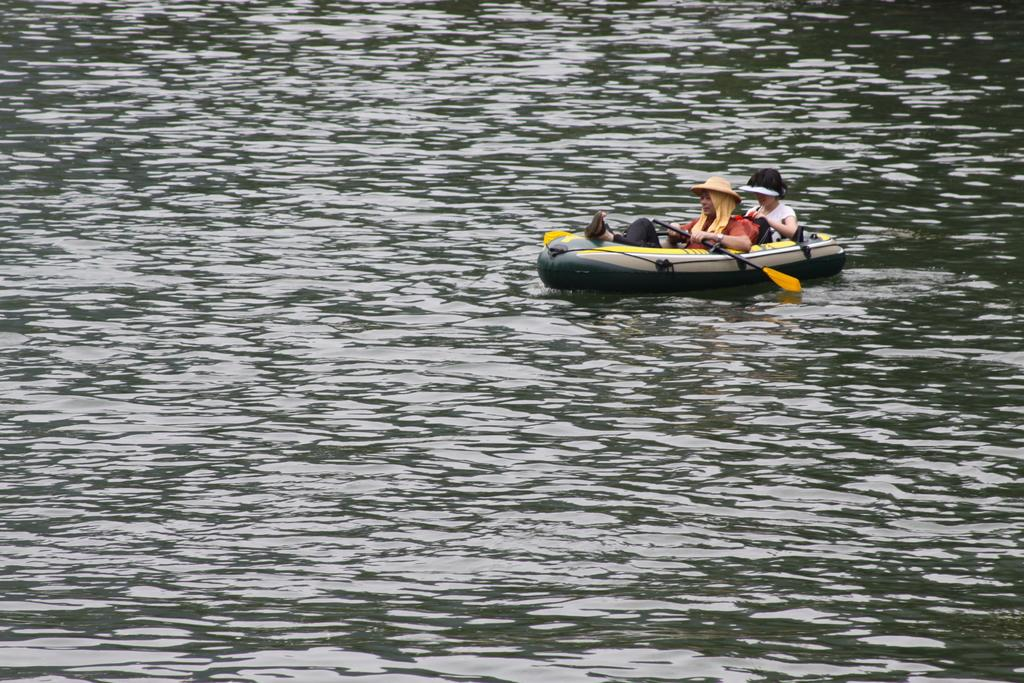How many people are in the image? There are two women in the image. What are the women holding in their hands? The women are holding paddles. What type of vehicle are the women sitting in? The women are sitting in an inflatable boat. Where is the boat located? The boat is floating in the water. What type of crack can be seen on the pan in the image? There is no pan or crack present in the image. 